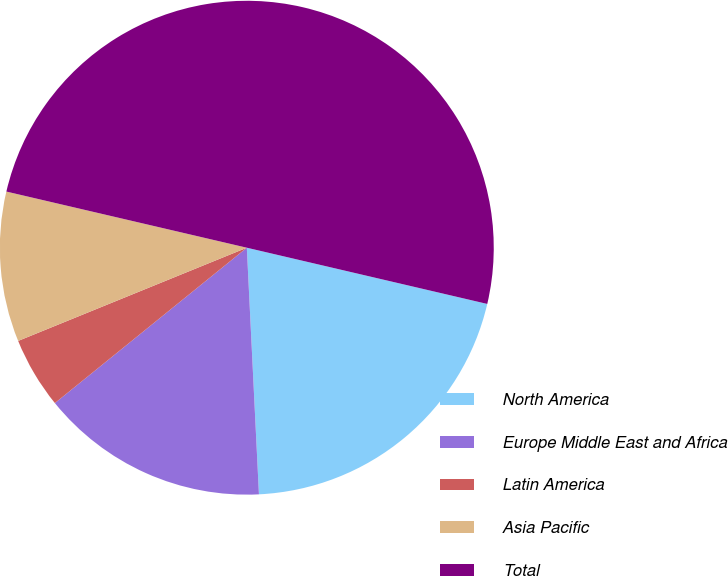Convert chart to OTSL. <chart><loc_0><loc_0><loc_500><loc_500><pie_chart><fcel>North America<fcel>Europe Middle East and Africa<fcel>Latin America<fcel>Asia Pacific<fcel>Total<nl><fcel>20.56%<fcel>14.95%<fcel>4.67%<fcel>9.81%<fcel>50.0%<nl></chart> 